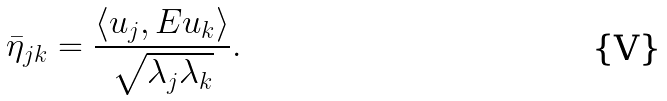Convert formula to latex. <formula><loc_0><loc_0><loc_500><loc_500>\bar { \eta } _ { j k } = \frac { \langle u _ { j } , E u _ { k } \rangle } { \sqrt { \lambda _ { j } \lambda _ { k } } } .</formula> 